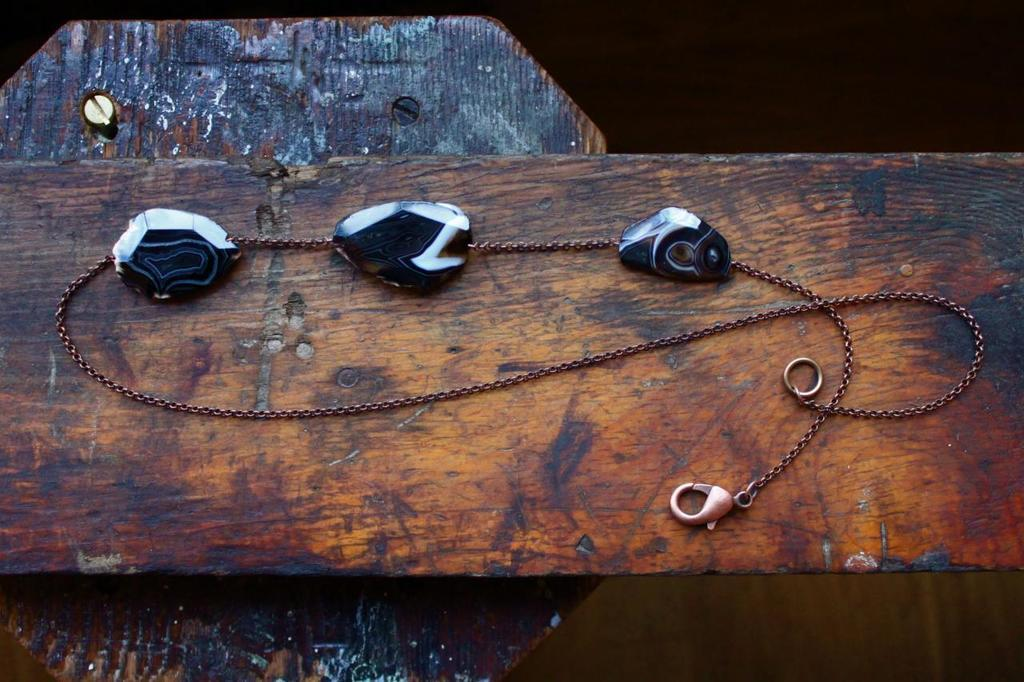What type of material is the main object in the image made of? The main object in the image is made of wood. What is attached to the wooden object? There is a chain attached to the wooden object. What color are the objects on the wooden object? The objects on the wooden object are black. Can you describe any additional features of the wooden object? There is a nail in the image. What is the overall appearance of the image's background? The background of the image is dark. Reasoning: To create the conversation, we first identify the main subject of the image, which is the wooden object. We then describe its material and any attachments or features, such as the chain and the nail. We also mention the color of the objects on the wooden object. Finally, we describe the background of the image, which is dark. Each question is designed to elicit a specific detail about the image that is known from the provided facts. Absurd Question/Answer: What type of quilt is being used to cover the vessel in the image? There is no quilt or vessel present in the image. What type of work is being performed on the wooden object in the image? There is no indication of any work being performed on the wooden object in the image. What type of quilt is being used to cover the vessel in the image? There is no quilt or vessel present in the image. What type of work is being performed on the wooden object in the image? There is no indication of any work being performed on the wooden object in the image. 